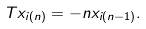<formula> <loc_0><loc_0><loc_500><loc_500>T x _ { i ( n ) } = - n x _ { i ( n - 1 ) } .</formula> 